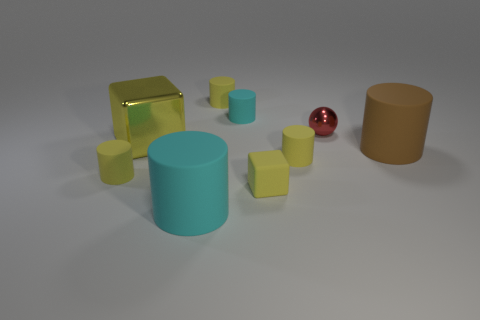What is the shape of the cyan object that is the same size as the brown rubber cylinder?
Give a very brief answer. Cylinder. Is there a brown object that has the same size as the yellow matte cube?
Ensure brevity in your answer.  No. What is the material of the cylinder that is the same size as the brown matte thing?
Your answer should be very brief. Rubber. There is a metallic object that is right of the yellow matte cylinder that is behind the small shiny object; what is its size?
Provide a short and direct response. Small. Does the cube on the right side of the yellow metallic thing have the same size as the small cyan rubber thing?
Your answer should be compact. Yes. Are there more rubber cylinders that are behind the large yellow metal block than cyan matte objects that are left of the red shiny sphere?
Keep it short and to the point. No. The big object that is both left of the tiny sphere and behind the tiny rubber block has what shape?
Your answer should be compact. Cube. The large rubber object left of the tiny red metallic thing has what shape?
Ensure brevity in your answer.  Cylinder. What size is the yellow cylinder that is to the left of the cyan cylinder left of the small yellow object that is behind the large yellow object?
Give a very brief answer. Small. Is the big metallic object the same shape as the brown thing?
Provide a short and direct response. No. 